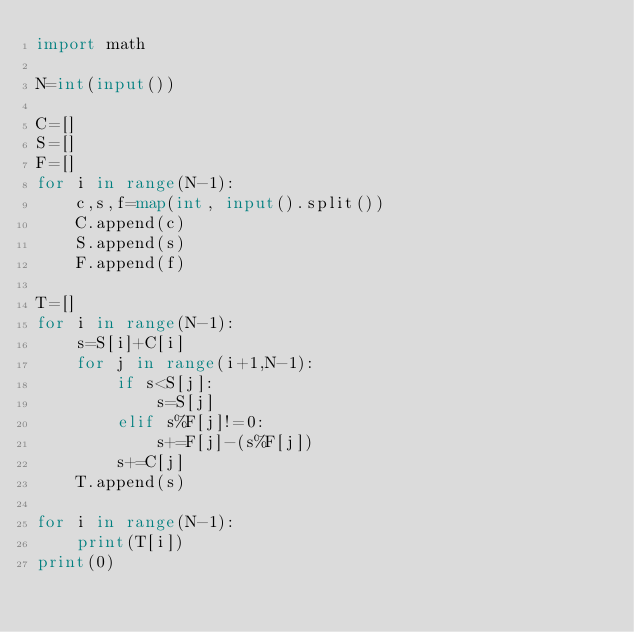<code> <loc_0><loc_0><loc_500><loc_500><_Python_>import math

N=int(input())

C=[]
S=[]
F=[]
for i in range(N-1):
    c,s,f=map(int, input().split())
    C.append(c)
    S.append(s)
    F.append(f)

T=[]
for i in range(N-1):
    s=S[i]+C[i]
    for j in range(i+1,N-1):
        if s<S[j]:
            s=S[j]
        elif s%F[j]!=0:
            s+=F[j]-(s%F[j])
        s+=C[j]
    T.append(s)

for i in range(N-1):
    print(T[i])
print(0)
</code> 